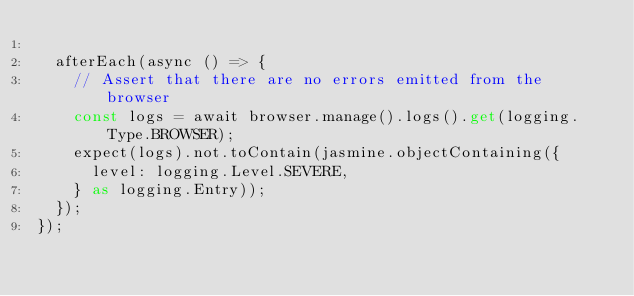<code> <loc_0><loc_0><loc_500><loc_500><_TypeScript_>
  afterEach(async () => {
    // Assert that there are no errors emitted from the browser
    const logs = await browser.manage().logs().get(logging.Type.BROWSER);
    expect(logs).not.toContain(jasmine.objectContaining({
      level: logging.Level.SEVERE,
    } as logging.Entry));
  });
});
</code> 